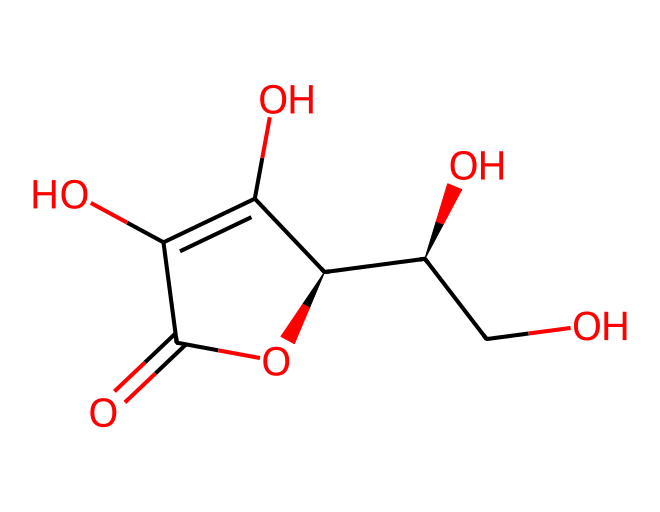how many carbon atoms are in the structure? Count the carbon atoms (C) in the SMILES representation. There are 6 carbon atoms in the ring and linear parts of the molecule.
Answer: six what functional groups are present in ascorbic acid? Identify the functional groups from the structure: the presence of hydroxyl (-OH) groups and a carbonyl (C=O) group indicates that hydroxyl and carbonyl functional groups are present.
Answer: hydroxyl and carbonyl is ascorbic acid a cyclic compound? Analyze the structure: there is a ring present (indicated by C1...C1), meaning it is a cyclic compound.
Answer: yes what is the molecular formula of ascorbic acid? Calculate the molecular formula based on the counts of C, H, and O from the structure: 6 carbon, 8 hydrogen, and 6 oxygen atoms lead to a molecular formula of C6H8O6.
Answer: C6H8O6 is ascorbic acid soluble in water? As a non-electrolyte with multiple hydroxyl groups, ascorbic acid is typically soluble in water due to hydrogen bonding.
Answer: yes do non-electrolytes conduct electricity in solution? Analyze the properties of non-electrolytes like ascorbic acid: they don't dissociate into ions when dissolved, so they do not conduct electricity in solution.
Answer: no 